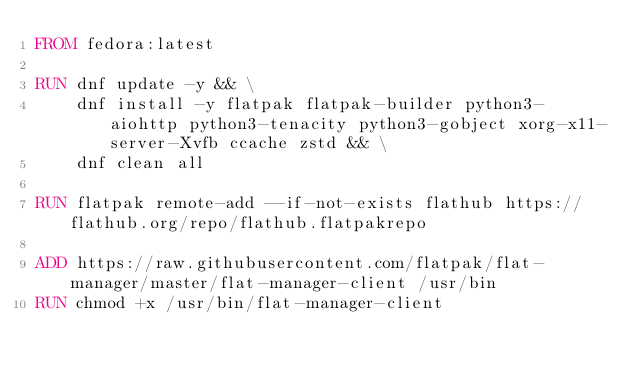<code> <loc_0><loc_0><loc_500><loc_500><_Dockerfile_>FROM fedora:latest

RUN dnf update -y && \
    dnf install -y flatpak flatpak-builder python3-aiohttp python3-tenacity python3-gobject xorg-x11-server-Xvfb ccache zstd && \
    dnf clean all

RUN flatpak remote-add --if-not-exists flathub https://flathub.org/repo/flathub.flatpakrepo

ADD https://raw.githubusercontent.com/flatpak/flat-manager/master/flat-manager-client /usr/bin
RUN chmod +x /usr/bin/flat-manager-client
</code> 